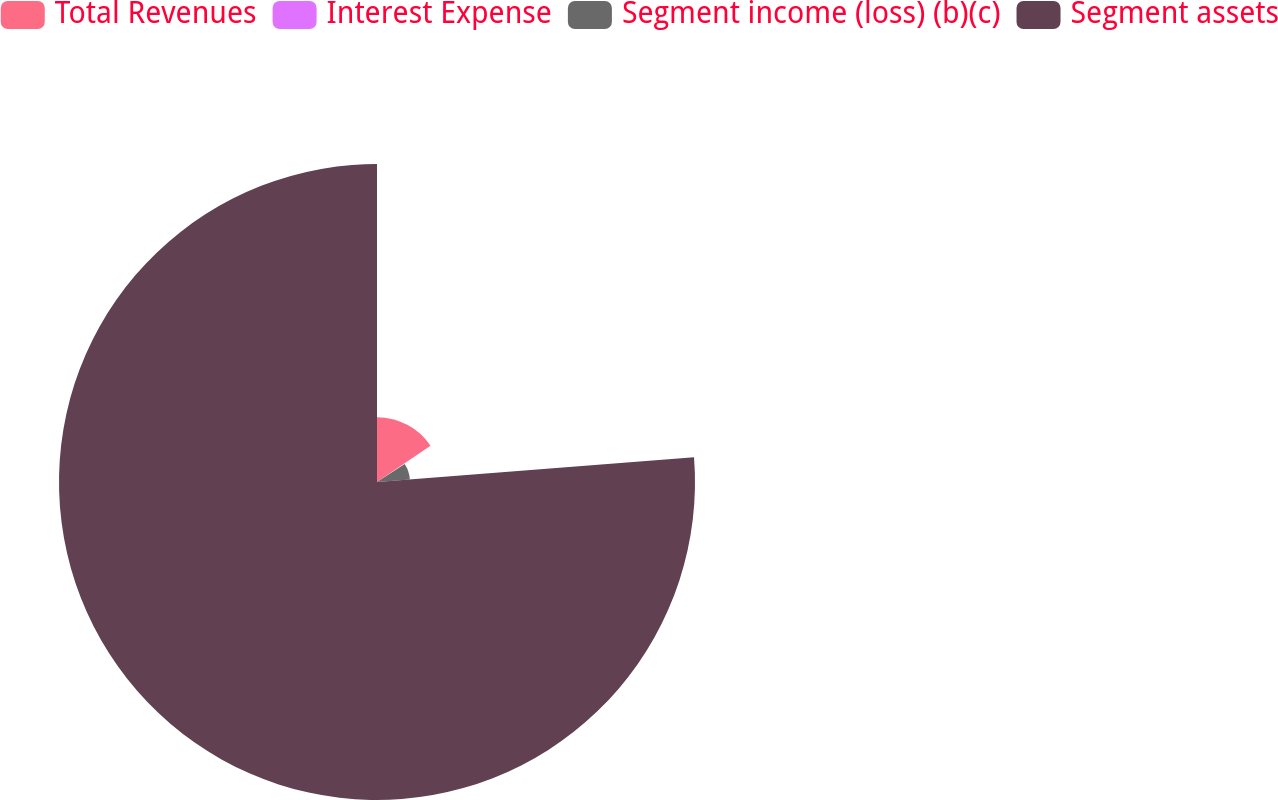Convert chart. <chart><loc_0><loc_0><loc_500><loc_500><pie_chart><fcel>Total Revenues<fcel>Interest Expense<fcel>Segment income (loss) (b)(c)<fcel>Segment assets<nl><fcel>15.51%<fcel>0.33%<fcel>7.92%<fcel>76.25%<nl></chart> 